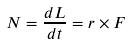<formula> <loc_0><loc_0><loc_500><loc_500>N = \frac { d L } { d t } = r \times F</formula> 